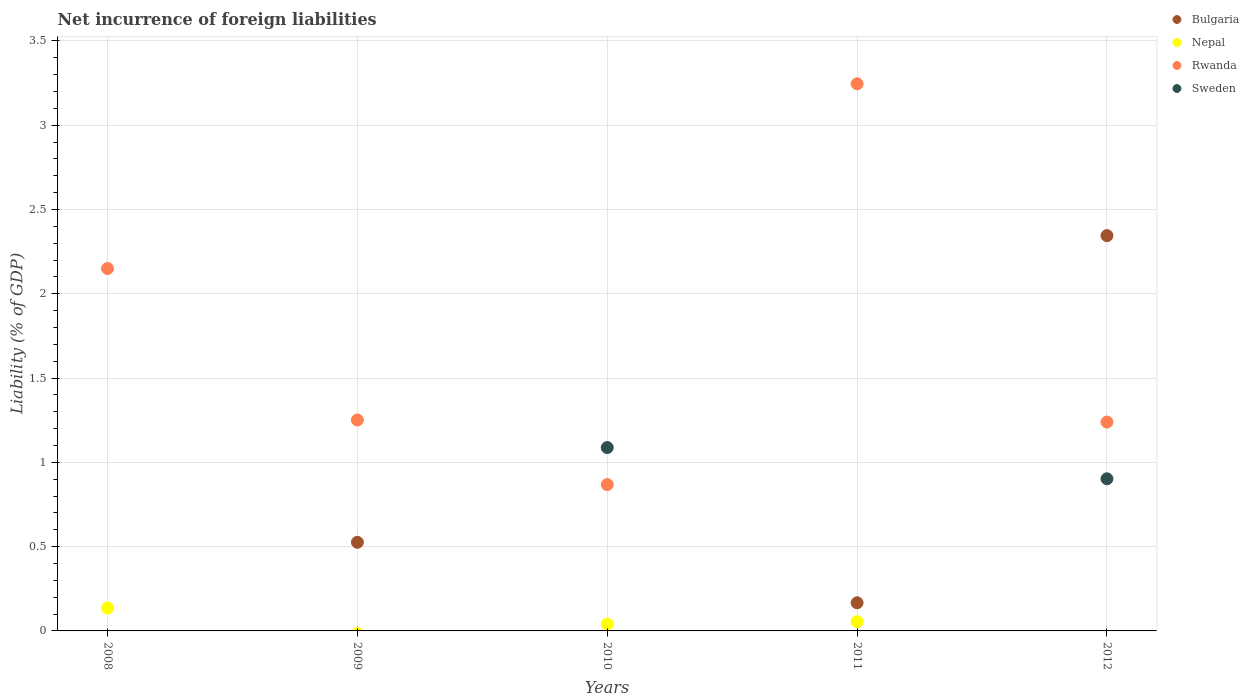How many different coloured dotlines are there?
Offer a terse response. 4. Across all years, what is the maximum net incurrence of foreign liabilities in Rwanda?
Your answer should be compact. 3.25. What is the total net incurrence of foreign liabilities in Sweden in the graph?
Make the answer very short. 1.99. What is the difference between the net incurrence of foreign liabilities in Nepal in 2008 and that in 2011?
Provide a short and direct response. 0.08. What is the difference between the net incurrence of foreign liabilities in Sweden in 2009 and the net incurrence of foreign liabilities in Nepal in 2008?
Keep it short and to the point. -0.14. What is the average net incurrence of foreign liabilities in Bulgaria per year?
Keep it short and to the point. 0.61. In the year 2012, what is the difference between the net incurrence of foreign liabilities in Bulgaria and net incurrence of foreign liabilities in Rwanda?
Provide a short and direct response. 1.11. What is the ratio of the net incurrence of foreign liabilities in Rwanda in 2010 to that in 2011?
Keep it short and to the point. 0.27. Is the difference between the net incurrence of foreign liabilities in Bulgaria in 2009 and 2012 greater than the difference between the net incurrence of foreign liabilities in Rwanda in 2009 and 2012?
Offer a very short reply. No. What is the difference between the highest and the second highest net incurrence of foreign liabilities in Bulgaria?
Keep it short and to the point. 1.82. What is the difference between the highest and the lowest net incurrence of foreign liabilities in Rwanda?
Keep it short and to the point. 2.38. Is the sum of the net incurrence of foreign liabilities in Nepal in 2010 and 2011 greater than the maximum net incurrence of foreign liabilities in Bulgaria across all years?
Your response must be concise. No. Is it the case that in every year, the sum of the net incurrence of foreign liabilities in Bulgaria and net incurrence of foreign liabilities in Nepal  is greater than the net incurrence of foreign liabilities in Rwanda?
Make the answer very short. No. Is the net incurrence of foreign liabilities in Rwanda strictly greater than the net incurrence of foreign liabilities in Bulgaria over the years?
Provide a short and direct response. No. Is the net incurrence of foreign liabilities in Nepal strictly less than the net incurrence of foreign liabilities in Bulgaria over the years?
Your answer should be compact. No. Does the graph contain any zero values?
Offer a terse response. Yes. How many legend labels are there?
Offer a terse response. 4. What is the title of the graph?
Offer a very short reply. Net incurrence of foreign liabilities. Does "Fragile and conflict affected situations" appear as one of the legend labels in the graph?
Ensure brevity in your answer.  No. What is the label or title of the Y-axis?
Offer a terse response. Liability (% of GDP). What is the Liability (% of GDP) of Bulgaria in 2008?
Offer a very short reply. 0. What is the Liability (% of GDP) in Nepal in 2008?
Keep it short and to the point. 0.14. What is the Liability (% of GDP) in Rwanda in 2008?
Your answer should be very brief. 2.15. What is the Liability (% of GDP) of Bulgaria in 2009?
Your answer should be compact. 0.53. What is the Liability (% of GDP) in Rwanda in 2009?
Your answer should be compact. 1.25. What is the Liability (% of GDP) in Sweden in 2009?
Provide a succinct answer. 0. What is the Liability (% of GDP) of Bulgaria in 2010?
Ensure brevity in your answer.  0. What is the Liability (% of GDP) of Nepal in 2010?
Your response must be concise. 0.04. What is the Liability (% of GDP) of Rwanda in 2010?
Give a very brief answer. 0.87. What is the Liability (% of GDP) of Sweden in 2010?
Offer a very short reply. 1.09. What is the Liability (% of GDP) of Bulgaria in 2011?
Your answer should be very brief. 0.17. What is the Liability (% of GDP) of Nepal in 2011?
Your answer should be very brief. 0.05. What is the Liability (% of GDP) of Rwanda in 2011?
Make the answer very short. 3.25. What is the Liability (% of GDP) in Bulgaria in 2012?
Your response must be concise. 2.34. What is the Liability (% of GDP) in Rwanda in 2012?
Ensure brevity in your answer.  1.24. What is the Liability (% of GDP) of Sweden in 2012?
Your response must be concise. 0.9. Across all years, what is the maximum Liability (% of GDP) in Bulgaria?
Give a very brief answer. 2.34. Across all years, what is the maximum Liability (% of GDP) of Nepal?
Your response must be concise. 0.14. Across all years, what is the maximum Liability (% of GDP) of Rwanda?
Your response must be concise. 3.25. Across all years, what is the maximum Liability (% of GDP) in Sweden?
Offer a terse response. 1.09. Across all years, what is the minimum Liability (% of GDP) of Bulgaria?
Your answer should be compact. 0. Across all years, what is the minimum Liability (% of GDP) in Rwanda?
Give a very brief answer. 0.87. Across all years, what is the minimum Liability (% of GDP) of Sweden?
Give a very brief answer. 0. What is the total Liability (% of GDP) of Bulgaria in the graph?
Keep it short and to the point. 3.04. What is the total Liability (% of GDP) of Nepal in the graph?
Provide a short and direct response. 0.23. What is the total Liability (% of GDP) of Rwanda in the graph?
Your answer should be very brief. 8.75. What is the total Liability (% of GDP) in Sweden in the graph?
Ensure brevity in your answer.  1.99. What is the difference between the Liability (% of GDP) in Rwanda in 2008 and that in 2009?
Ensure brevity in your answer.  0.9. What is the difference between the Liability (% of GDP) in Nepal in 2008 and that in 2010?
Your answer should be compact. 0.1. What is the difference between the Liability (% of GDP) in Rwanda in 2008 and that in 2010?
Offer a very short reply. 1.28. What is the difference between the Liability (% of GDP) in Nepal in 2008 and that in 2011?
Your answer should be very brief. 0.08. What is the difference between the Liability (% of GDP) of Rwanda in 2008 and that in 2011?
Your answer should be compact. -1.1. What is the difference between the Liability (% of GDP) of Rwanda in 2008 and that in 2012?
Your response must be concise. 0.91. What is the difference between the Liability (% of GDP) in Rwanda in 2009 and that in 2010?
Keep it short and to the point. 0.38. What is the difference between the Liability (% of GDP) of Bulgaria in 2009 and that in 2011?
Make the answer very short. 0.36. What is the difference between the Liability (% of GDP) in Rwanda in 2009 and that in 2011?
Make the answer very short. -1.99. What is the difference between the Liability (% of GDP) in Bulgaria in 2009 and that in 2012?
Provide a short and direct response. -1.82. What is the difference between the Liability (% of GDP) in Rwanda in 2009 and that in 2012?
Keep it short and to the point. 0.01. What is the difference between the Liability (% of GDP) of Nepal in 2010 and that in 2011?
Provide a succinct answer. -0.01. What is the difference between the Liability (% of GDP) of Rwanda in 2010 and that in 2011?
Provide a succinct answer. -2.38. What is the difference between the Liability (% of GDP) of Rwanda in 2010 and that in 2012?
Your answer should be compact. -0.37. What is the difference between the Liability (% of GDP) in Sweden in 2010 and that in 2012?
Offer a terse response. 0.19. What is the difference between the Liability (% of GDP) in Bulgaria in 2011 and that in 2012?
Your answer should be very brief. -2.18. What is the difference between the Liability (% of GDP) in Rwanda in 2011 and that in 2012?
Offer a terse response. 2.01. What is the difference between the Liability (% of GDP) of Nepal in 2008 and the Liability (% of GDP) of Rwanda in 2009?
Give a very brief answer. -1.12. What is the difference between the Liability (% of GDP) in Nepal in 2008 and the Liability (% of GDP) in Rwanda in 2010?
Your answer should be compact. -0.73. What is the difference between the Liability (% of GDP) of Nepal in 2008 and the Liability (% of GDP) of Sweden in 2010?
Provide a short and direct response. -0.95. What is the difference between the Liability (% of GDP) in Rwanda in 2008 and the Liability (% of GDP) in Sweden in 2010?
Offer a terse response. 1.06. What is the difference between the Liability (% of GDP) in Nepal in 2008 and the Liability (% of GDP) in Rwanda in 2011?
Provide a succinct answer. -3.11. What is the difference between the Liability (% of GDP) in Nepal in 2008 and the Liability (% of GDP) in Rwanda in 2012?
Ensure brevity in your answer.  -1.1. What is the difference between the Liability (% of GDP) in Nepal in 2008 and the Liability (% of GDP) in Sweden in 2012?
Your response must be concise. -0.77. What is the difference between the Liability (% of GDP) in Rwanda in 2008 and the Liability (% of GDP) in Sweden in 2012?
Provide a succinct answer. 1.25. What is the difference between the Liability (% of GDP) of Bulgaria in 2009 and the Liability (% of GDP) of Nepal in 2010?
Make the answer very short. 0.49. What is the difference between the Liability (% of GDP) in Bulgaria in 2009 and the Liability (% of GDP) in Rwanda in 2010?
Make the answer very short. -0.34. What is the difference between the Liability (% of GDP) in Bulgaria in 2009 and the Liability (% of GDP) in Sweden in 2010?
Your response must be concise. -0.56. What is the difference between the Liability (% of GDP) in Rwanda in 2009 and the Liability (% of GDP) in Sweden in 2010?
Your answer should be compact. 0.16. What is the difference between the Liability (% of GDP) of Bulgaria in 2009 and the Liability (% of GDP) of Nepal in 2011?
Provide a succinct answer. 0.47. What is the difference between the Liability (% of GDP) of Bulgaria in 2009 and the Liability (% of GDP) of Rwanda in 2011?
Your answer should be very brief. -2.72. What is the difference between the Liability (% of GDP) of Bulgaria in 2009 and the Liability (% of GDP) of Rwanda in 2012?
Give a very brief answer. -0.71. What is the difference between the Liability (% of GDP) of Bulgaria in 2009 and the Liability (% of GDP) of Sweden in 2012?
Make the answer very short. -0.38. What is the difference between the Liability (% of GDP) in Rwanda in 2009 and the Liability (% of GDP) in Sweden in 2012?
Ensure brevity in your answer.  0.35. What is the difference between the Liability (% of GDP) in Nepal in 2010 and the Liability (% of GDP) in Rwanda in 2011?
Your answer should be compact. -3.21. What is the difference between the Liability (% of GDP) in Nepal in 2010 and the Liability (% of GDP) in Rwanda in 2012?
Ensure brevity in your answer.  -1.2. What is the difference between the Liability (% of GDP) of Nepal in 2010 and the Liability (% of GDP) of Sweden in 2012?
Provide a short and direct response. -0.86. What is the difference between the Liability (% of GDP) in Rwanda in 2010 and the Liability (% of GDP) in Sweden in 2012?
Make the answer very short. -0.03. What is the difference between the Liability (% of GDP) in Bulgaria in 2011 and the Liability (% of GDP) in Rwanda in 2012?
Provide a short and direct response. -1.07. What is the difference between the Liability (% of GDP) of Bulgaria in 2011 and the Liability (% of GDP) of Sweden in 2012?
Give a very brief answer. -0.74. What is the difference between the Liability (% of GDP) of Nepal in 2011 and the Liability (% of GDP) of Rwanda in 2012?
Make the answer very short. -1.18. What is the difference between the Liability (% of GDP) of Nepal in 2011 and the Liability (% of GDP) of Sweden in 2012?
Offer a very short reply. -0.85. What is the difference between the Liability (% of GDP) of Rwanda in 2011 and the Liability (% of GDP) of Sweden in 2012?
Keep it short and to the point. 2.34. What is the average Liability (% of GDP) of Bulgaria per year?
Keep it short and to the point. 0.61. What is the average Liability (% of GDP) of Nepal per year?
Give a very brief answer. 0.05. What is the average Liability (% of GDP) of Rwanda per year?
Provide a succinct answer. 1.75. What is the average Liability (% of GDP) of Sweden per year?
Make the answer very short. 0.4. In the year 2008, what is the difference between the Liability (% of GDP) of Nepal and Liability (% of GDP) of Rwanda?
Keep it short and to the point. -2.01. In the year 2009, what is the difference between the Liability (% of GDP) of Bulgaria and Liability (% of GDP) of Rwanda?
Keep it short and to the point. -0.73. In the year 2010, what is the difference between the Liability (% of GDP) in Nepal and Liability (% of GDP) in Rwanda?
Provide a short and direct response. -0.83. In the year 2010, what is the difference between the Liability (% of GDP) of Nepal and Liability (% of GDP) of Sweden?
Your answer should be compact. -1.05. In the year 2010, what is the difference between the Liability (% of GDP) in Rwanda and Liability (% of GDP) in Sweden?
Make the answer very short. -0.22. In the year 2011, what is the difference between the Liability (% of GDP) in Bulgaria and Liability (% of GDP) in Nepal?
Offer a terse response. 0.11. In the year 2011, what is the difference between the Liability (% of GDP) in Bulgaria and Liability (% of GDP) in Rwanda?
Make the answer very short. -3.08. In the year 2011, what is the difference between the Liability (% of GDP) of Nepal and Liability (% of GDP) of Rwanda?
Provide a succinct answer. -3.19. In the year 2012, what is the difference between the Liability (% of GDP) in Bulgaria and Liability (% of GDP) in Rwanda?
Keep it short and to the point. 1.11. In the year 2012, what is the difference between the Liability (% of GDP) of Bulgaria and Liability (% of GDP) of Sweden?
Ensure brevity in your answer.  1.44. In the year 2012, what is the difference between the Liability (% of GDP) in Rwanda and Liability (% of GDP) in Sweden?
Offer a terse response. 0.34. What is the ratio of the Liability (% of GDP) in Rwanda in 2008 to that in 2009?
Your answer should be compact. 1.72. What is the ratio of the Liability (% of GDP) of Nepal in 2008 to that in 2010?
Make the answer very short. 3.38. What is the ratio of the Liability (% of GDP) in Rwanda in 2008 to that in 2010?
Offer a terse response. 2.48. What is the ratio of the Liability (% of GDP) in Nepal in 2008 to that in 2011?
Offer a very short reply. 2.48. What is the ratio of the Liability (% of GDP) in Rwanda in 2008 to that in 2011?
Keep it short and to the point. 0.66. What is the ratio of the Liability (% of GDP) in Rwanda in 2008 to that in 2012?
Offer a terse response. 1.73. What is the ratio of the Liability (% of GDP) in Rwanda in 2009 to that in 2010?
Offer a terse response. 1.44. What is the ratio of the Liability (% of GDP) in Bulgaria in 2009 to that in 2011?
Your answer should be compact. 3.15. What is the ratio of the Liability (% of GDP) of Rwanda in 2009 to that in 2011?
Ensure brevity in your answer.  0.39. What is the ratio of the Liability (% of GDP) of Bulgaria in 2009 to that in 2012?
Ensure brevity in your answer.  0.22. What is the ratio of the Liability (% of GDP) in Rwanda in 2009 to that in 2012?
Offer a very short reply. 1.01. What is the ratio of the Liability (% of GDP) in Nepal in 2010 to that in 2011?
Your answer should be compact. 0.73. What is the ratio of the Liability (% of GDP) of Rwanda in 2010 to that in 2011?
Make the answer very short. 0.27. What is the ratio of the Liability (% of GDP) of Rwanda in 2010 to that in 2012?
Give a very brief answer. 0.7. What is the ratio of the Liability (% of GDP) in Sweden in 2010 to that in 2012?
Offer a very short reply. 1.21. What is the ratio of the Liability (% of GDP) of Bulgaria in 2011 to that in 2012?
Keep it short and to the point. 0.07. What is the ratio of the Liability (% of GDP) of Rwanda in 2011 to that in 2012?
Provide a succinct answer. 2.62. What is the difference between the highest and the second highest Liability (% of GDP) in Bulgaria?
Give a very brief answer. 1.82. What is the difference between the highest and the second highest Liability (% of GDP) of Nepal?
Offer a terse response. 0.08. What is the difference between the highest and the second highest Liability (% of GDP) in Rwanda?
Offer a very short reply. 1.1. What is the difference between the highest and the lowest Liability (% of GDP) of Bulgaria?
Your response must be concise. 2.34. What is the difference between the highest and the lowest Liability (% of GDP) of Nepal?
Keep it short and to the point. 0.14. What is the difference between the highest and the lowest Liability (% of GDP) of Rwanda?
Your response must be concise. 2.38. What is the difference between the highest and the lowest Liability (% of GDP) of Sweden?
Provide a short and direct response. 1.09. 